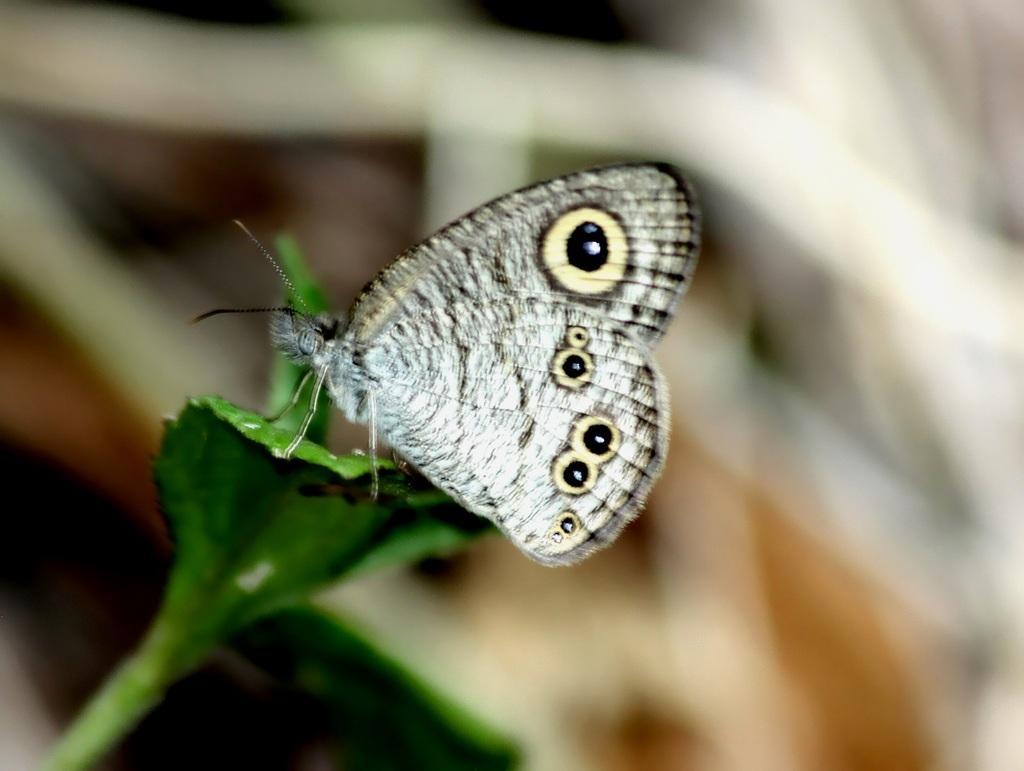Can you describe this image briefly? In this image, in the middle, we can see a butterfly which is on the leaf. In the background, we can see white color. 